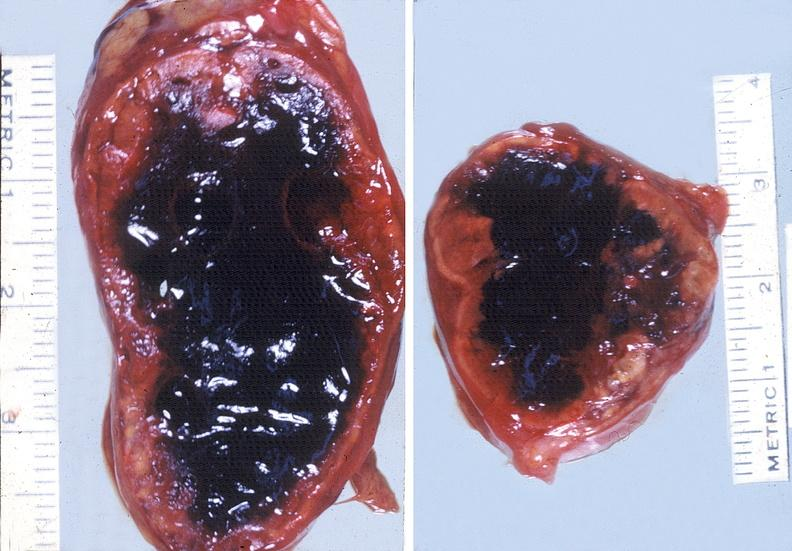what is present?
Answer the question using a single word or phrase. Endocrine 